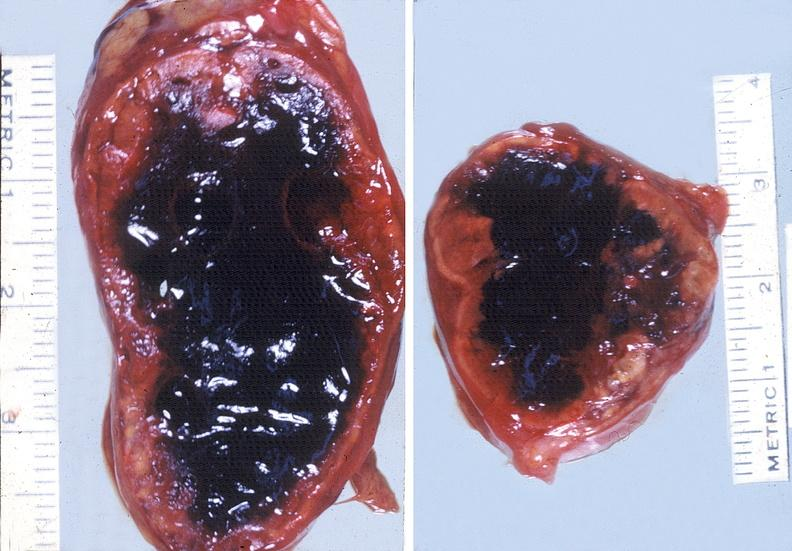what is present?
Answer the question using a single word or phrase. Endocrine 